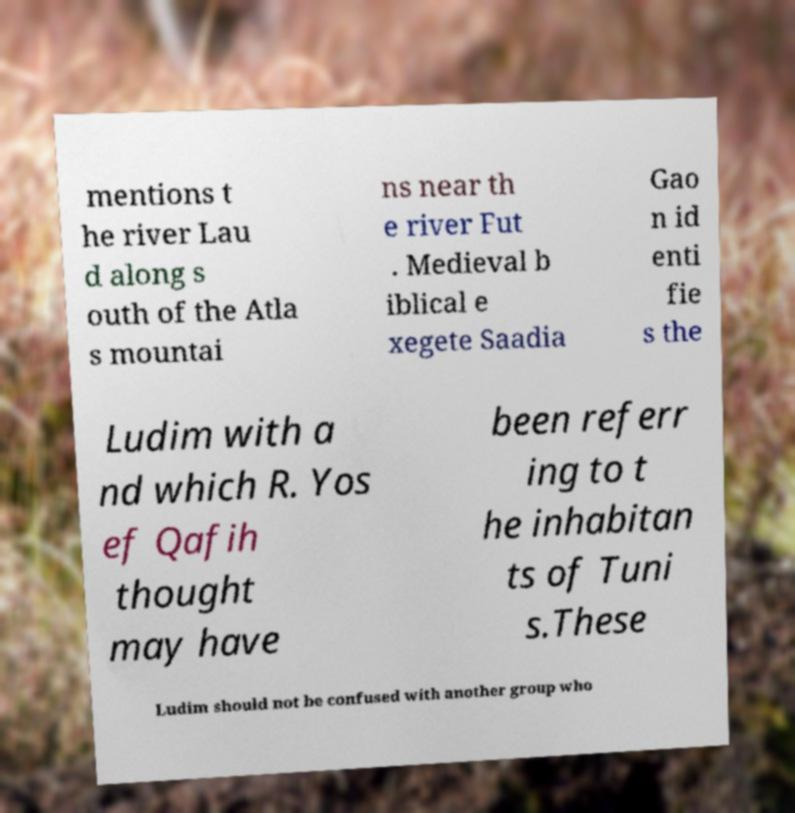I need the written content from this picture converted into text. Can you do that? mentions t he river Lau d along s outh of the Atla s mountai ns near th e river Fut . Medieval b iblical e xegete Saadia Gao n id enti fie s the Ludim with a nd which R. Yos ef Qafih thought may have been referr ing to t he inhabitan ts of Tuni s.These Ludim should not be confused with another group who 